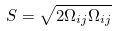<formula> <loc_0><loc_0><loc_500><loc_500>S = \sqrt { 2 \Omega _ { i j } \Omega _ { i j } }</formula> 